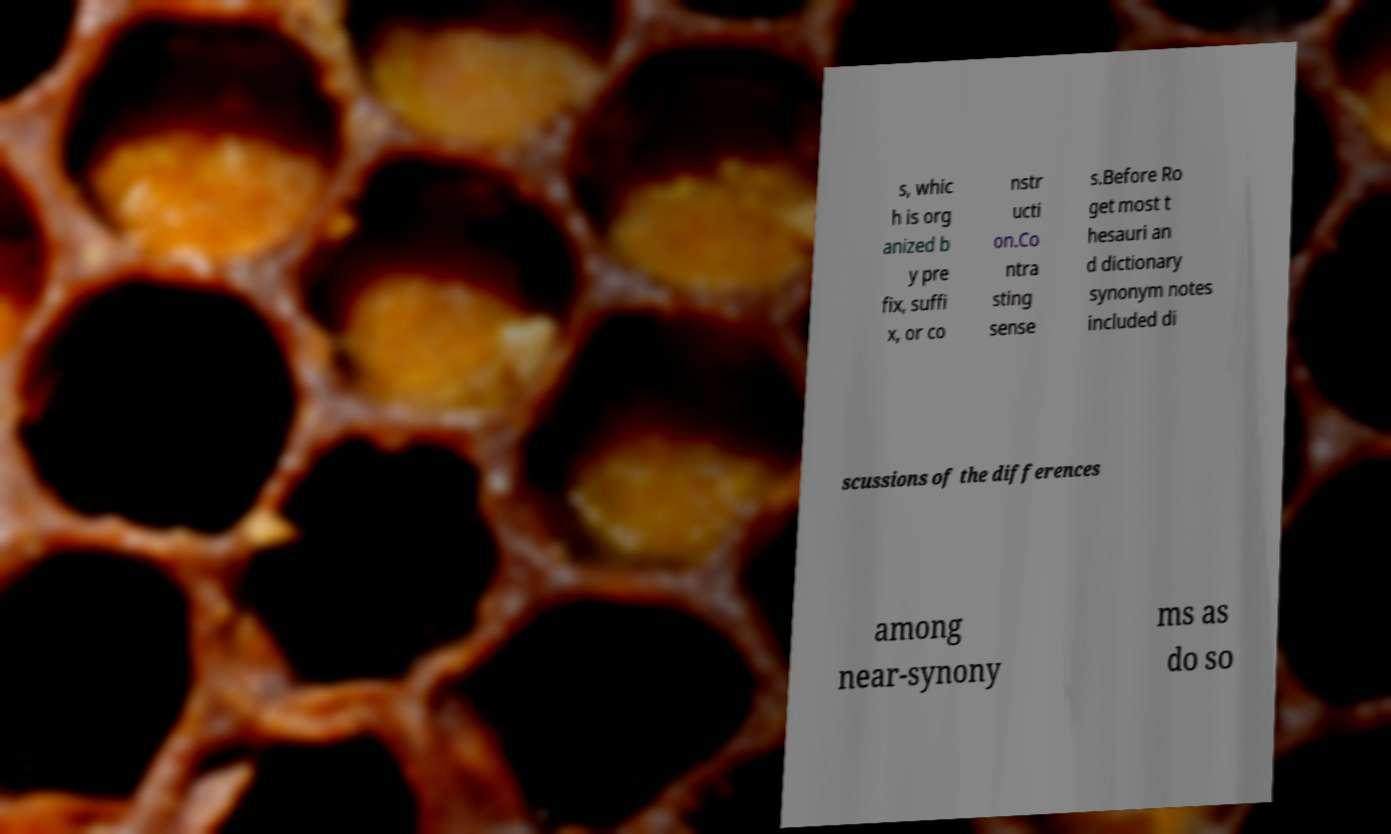Please read and relay the text visible in this image. What does it say? s, whic h is org anized b y pre fix, suffi x, or co nstr ucti on.Co ntra sting sense s.Before Ro get most t hesauri an d dictionary synonym notes included di scussions of the differences among near-synony ms as do so 